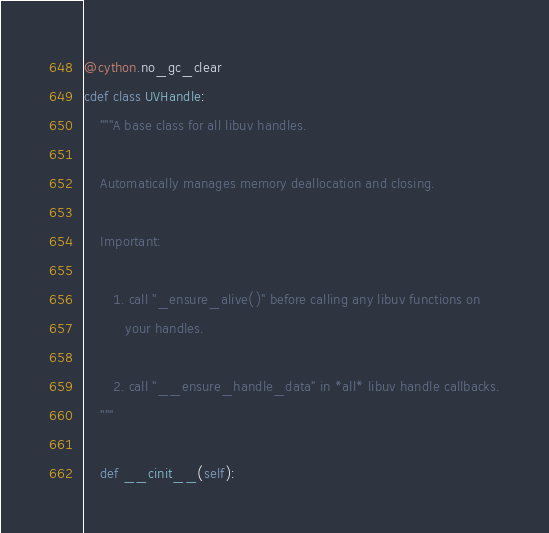Convert code to text. <code><loc_0><loc_0><loc_500><loc_500><_Cython_>@cython.no_gc_clear
cdef class UVHandle:
    """A base class for all libuv handles.

    Automatically manages memory deallocation and closing.

    Important:

       1. call "_ensure_alive()" before calling any libuv functions on
          your handles.

       2. call "__ensure_handle_data" in *all* libuv handle callbacks.
    """

    def __cinit__(self):</code> 